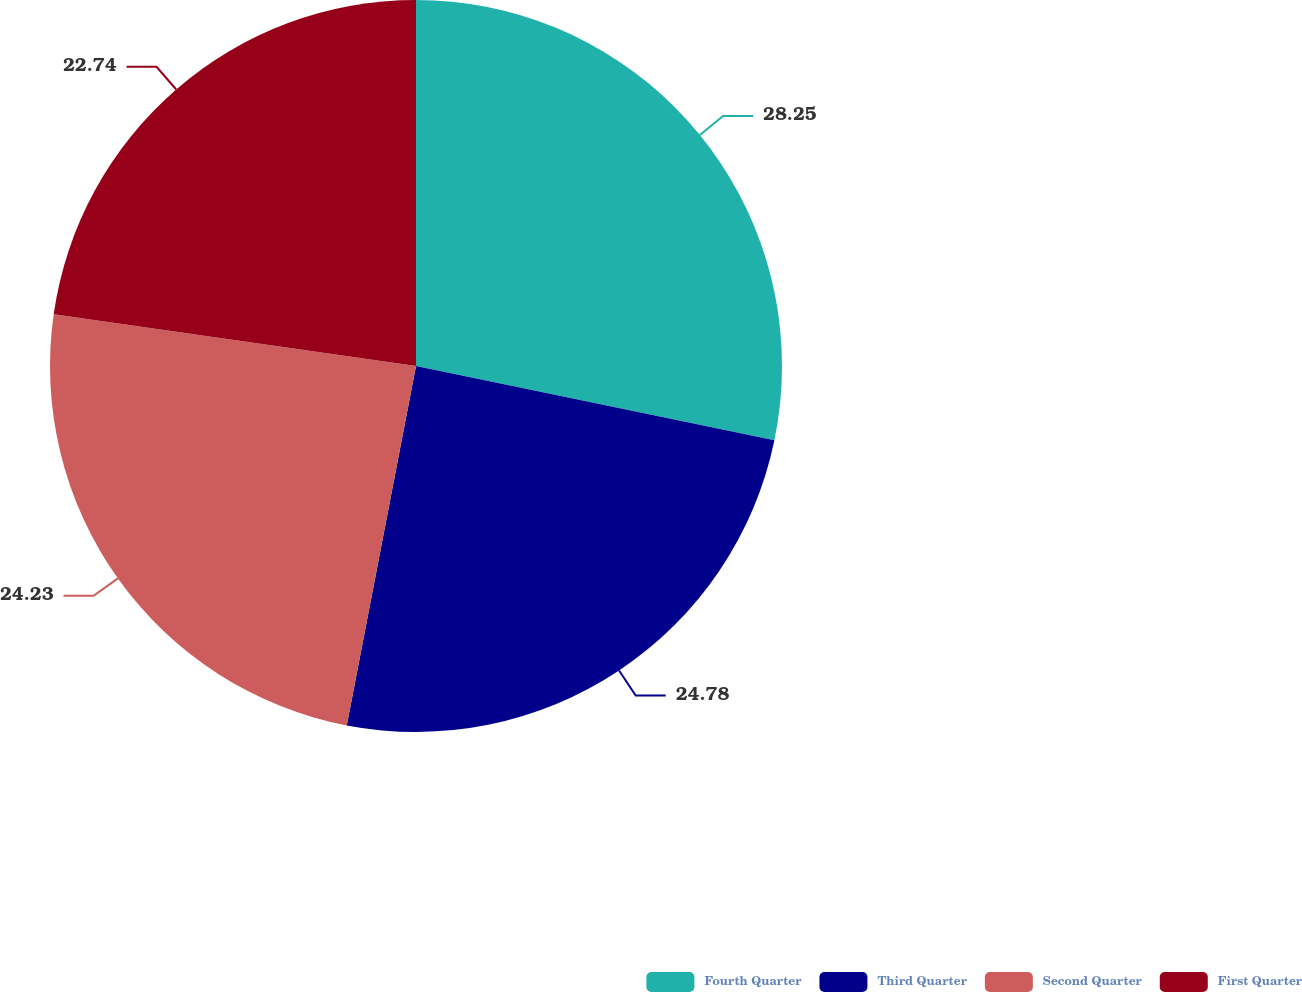Convert chart. <chart><loc_0><loc_0><loc_500><loc_500><pie_chart><fcel>Fourth Quarter<fcel>Third Quarter<fcel>Second Quarter<fcel>First Quarter<nl><fcel>28.25%<fcel>24.78%<fcel>24.23%<fcel>22.74%<nl></chart> 